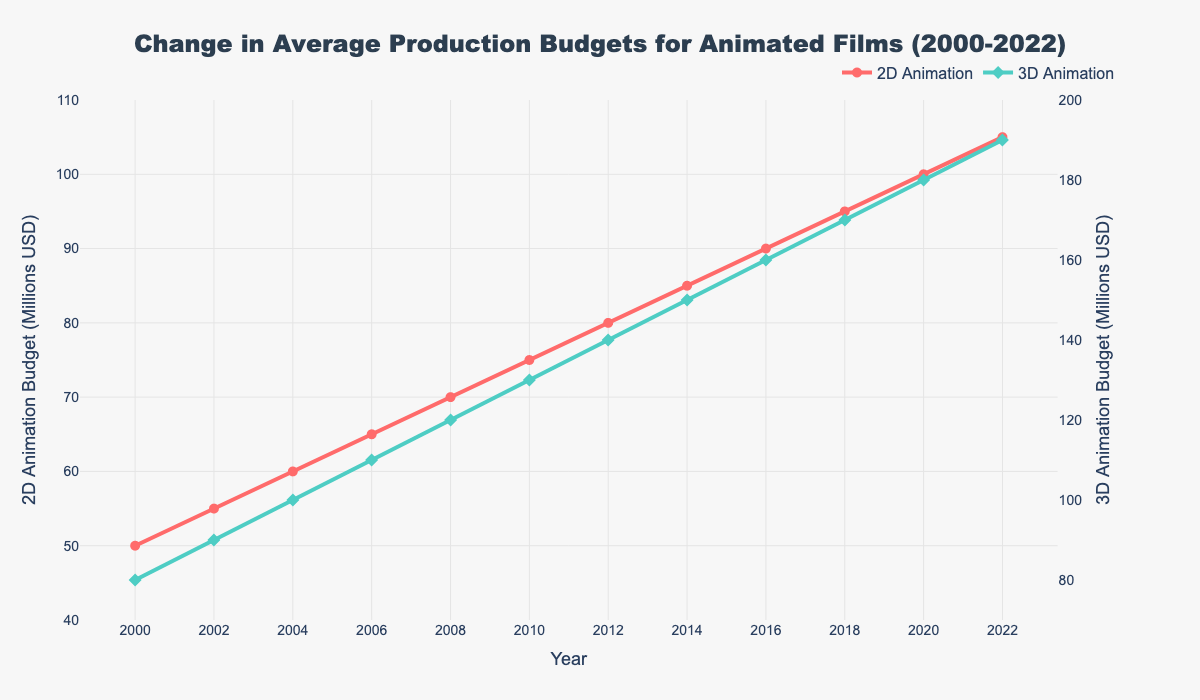What is the trend for 2D Animation budgets from 2000 to 2022? The trend for 2D Animation budgets can be determined by observing the slope of the red line for 2D Animation over the years. From 2000 to 2022, the 2D Animation budget shows a consistent upward trend, increasing by $5 million every two years.
Answer: Upward trend Between which years did the 3D Animation budget experience the highest increase? By examining the green line for 3D Animation budgets, we can see the differences in slope between each year. The highest increase happens between 2000 ($80M) and 2022 ($190M), with $110 million increment but visually, the increments are fairly consistent every two years at $10 million.
Answer: Overall consistent, largest increase spanning all years What was the 2D Animation budget in 2010 and how much did it increase by 2022? Locate the 2D Animation data point for 2010 on the red line, which is $75 million, and then find the 2022 data point, which is $105 million. The increase is $105M - $75M.
Answer: $75M, increased by $30M How did the production budgets for 2D and 3D Animation compare in the year 2016? In 2016, refer to the respective data points for 2D and 3D Animation. The 2D Animation budget is $90 million while the 3D Animation budget is $160 million. Comparing these, the 3D Animation budget is $70 million higher.
Answer: 2D: $90M, 3D: $160M, difference: $70M What were the average budgets for 2D Animation and 3D Animation from 2000 to 2022? To find the average, sum all budget values for each animation type from 2000 to 2022 and divide by the number of years. Sum for 2D Animation: (50 + 55 + 60 + 65 + 70 + 75 + 80 + 85 + 90 + 95 + 100 + 105) = $930M, Average = $930M/12. Sum for 3D Animation: (80 + 90 + 100 + 110 + 120 + 130 + 140 + 150 + 160 + 170 + 180 + 190) = $1620M, Average = $1620M/12.
Answer: 2D: $77.5M, 3D: $135M In which year did the budget for 3D Animation reach or surpass $150 million? Follow the green line (3D Animation) from left to right until it crosses the $150M mark on the y-axis. It surpasses $150 million in 2014.
Answer: 2014 By how much did the budget for 2D Animation increase every year on average between 2000 and 2022? Take the total 2D Animation budget increase from 2000 ($50M) to 2022 ($105M), which is $55 million, and divide by the number of years between them, which is 22. The average increase per year is $55M/22.
Answer: $2.5M What was the difference between the 2D and 3D Animation budgets in 2002? Refer to the 2002 data points: 2D Animation budget is $55 million and 3D Animation budget is $90 million. The difference is $90M - $55M.
Answer: $35M What is the approximate color used to represent 3D Animation in the figure? The color used for 3D Animation can be identified by looking at the legend or the line corresponding to 3D Animation. The color is green.
Answer: Green 